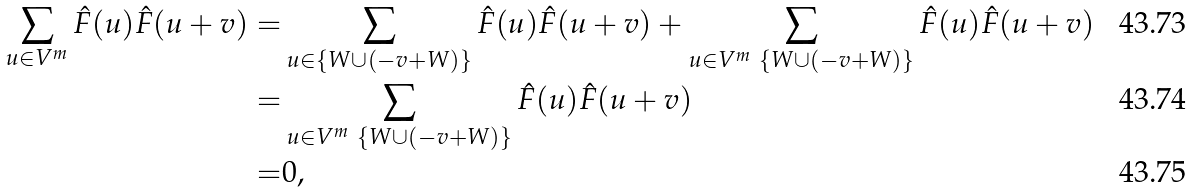Convert formula to latex. <formula><loc_0><loc_0><loc_500><loc_500>\sum _ { u \in V ^ { m } } \hat { F } ( u ) \hat { F } ( u + v ) = & \sum _ { u \in \{ W \cup ( - v + W ) \} } \hat { F } ( u ) \hat { F } ( u + v ) + \sum _ { u \in V ^ { m } \ \{ W \cup ( - v + W ) \} } \hat { F } ( u ) \hat { F } ( u + v ) \\ = & \sum _ { u \in V ^ { m } \ \{ W \cup ( - v + W ) \} } \hat { F } ( u ) \hat { F } ( u + v ) \\ = & 0 ,</formula> 